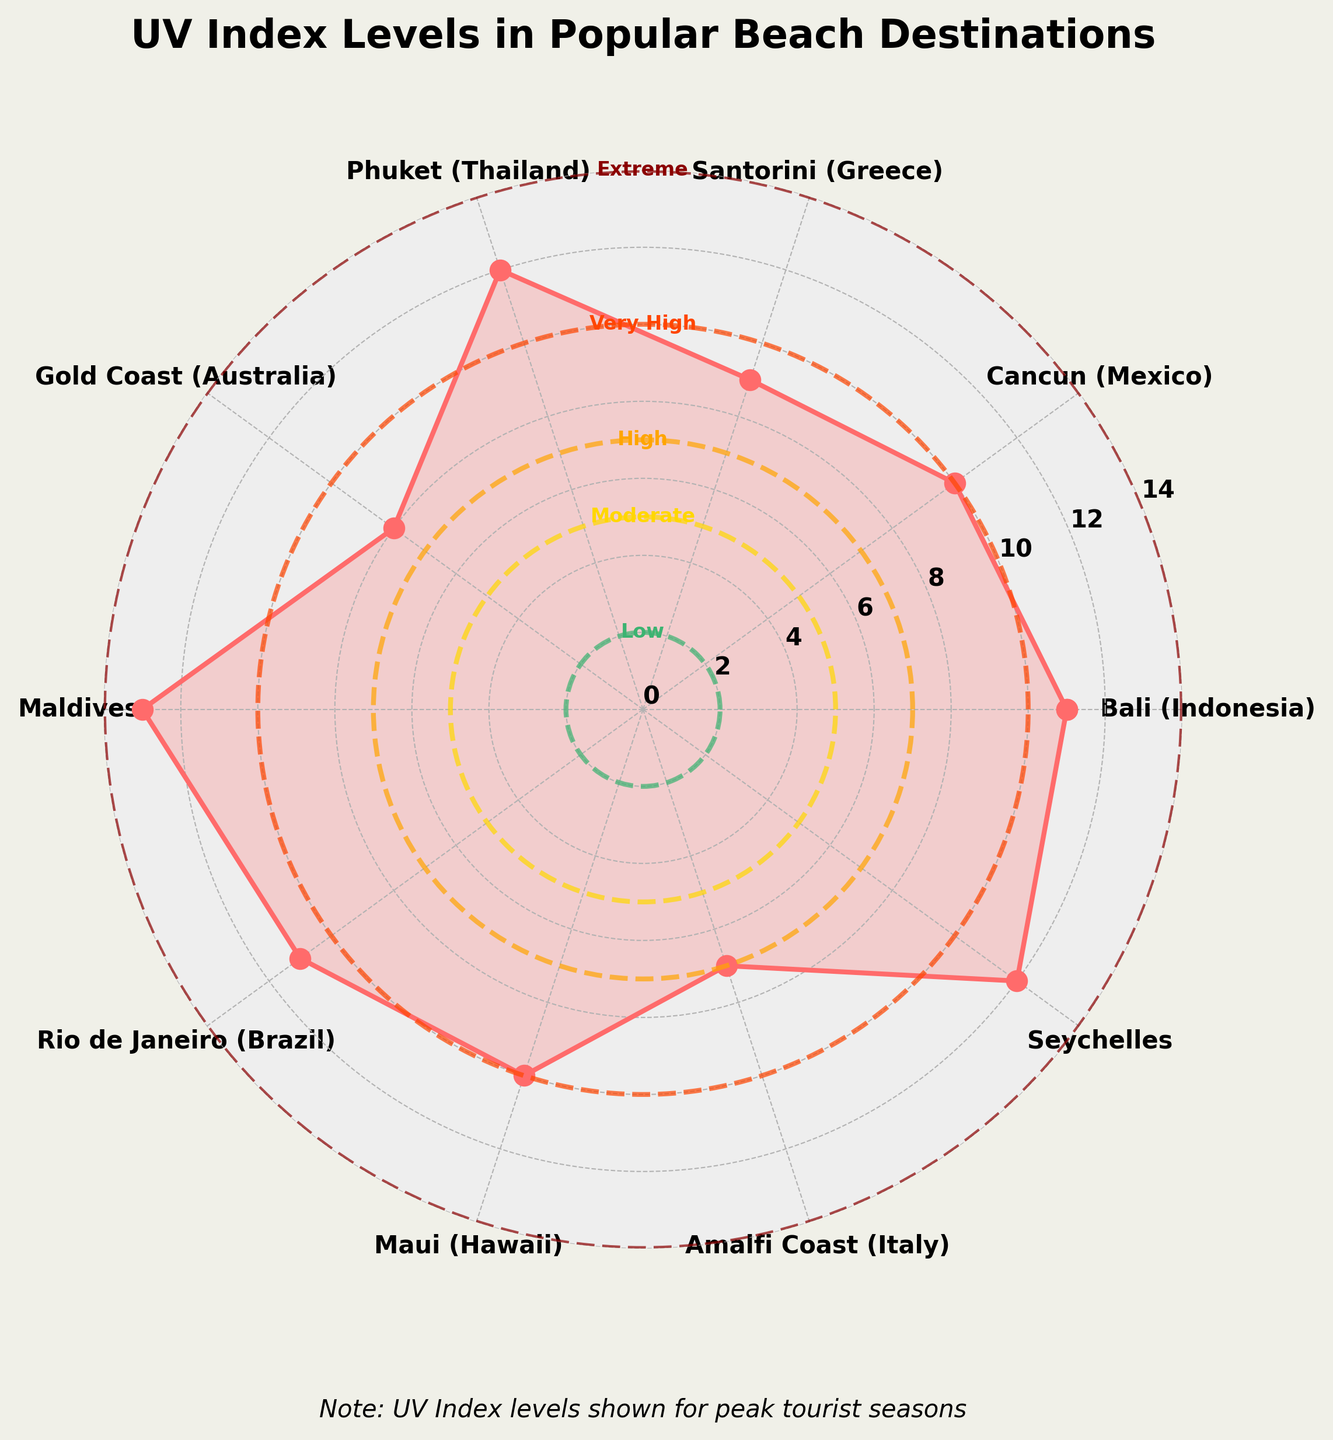Which beach destination has the highest UV Index? To determine which location has the highest UV Index, look for the data point on the gauge chart that is positioned the furthest out on the radial plot. The Maldives has the highest UV Index, as it reaches the most distant point from the center at 13.
Answer: Maldives What's the range of UV Index values shown in the chart? The range is calculated by subtracting the smallest UV Index value from the largest. Here, the smallest UV Index is 7 (Amalfi Coast), and the highest is 13 (Maldives). So, the range is 13 - 7 = 6.
Answer: 6 How many beach destinations have UV Index values classified as 'Extreme'? 'Extreme' UV Index values range from 11 to 14 according to the colors and labels on the chart. The locations with UV Index values in this range are Bali (11), Phuket (12), Maldives (13), Rio de Janeiro (11), and Seychelles (12). Counting these gives us 5 destinations.
Answer: 5 Which two destinations have the same UV Index level of 11? By examining the marked UV Index values, Bali (Indonesia) and Rio de Janeiro (Brazil) both register an index of 11.
Answer: Bali (Indonesia) and Rio de Janeiro (Brazil) How many destinations have UV Index values in the 'High' and 'Very High' ranges combined? 'High' range is from 7 to 10, and 'Very High' is from 10 to 11 as indicated by the chart labels. Destinations in the "High" range are Gold Coast (8) and Amalfi Coast (7), and in the "Very High" range are Cancun (10) and Maui (10). Combining these categories, we get 2 (High) + 2 (Very High) = 4 destinations.
Answer: 4 What's the average UV Index of all the destinations? Calculate the average by summing all the UV index values and dividing by the number of destinations. The sum of UV index values (11, 10, 9, 12, 8, 13, 11, 10, 7, 12) is 103. There are 10 destinations, so the average is 103 / 10 = 10.3.
Answer: 10.3 What's the difference in UV Index between the location with the lowest and the highest UV Index? The lowest UV Index is Amalfi Coast (7) and the highest is Maldives (13). The difference is 13 - 7 = 6.
Answer: 6 Which locations fall into the 'Moderate' UV Index category, and what is their average UV Index? 'Moderate' UV Index range is 3 to 5. None of the listed locations fall within this range, so the average UV Index for this category is not applicable.
Answer: None Which destinations have UV Index values higher than 10? The chart shows that destinations with UV Index values higher than 10 (11 and above) are Bali (11), Phuket (12), Maldives (13), Rio de Janeiro (11), and Seychelles (12).
Answer: Bali, Phuket, Maldives, Rio de Janeiro, Seychelles 